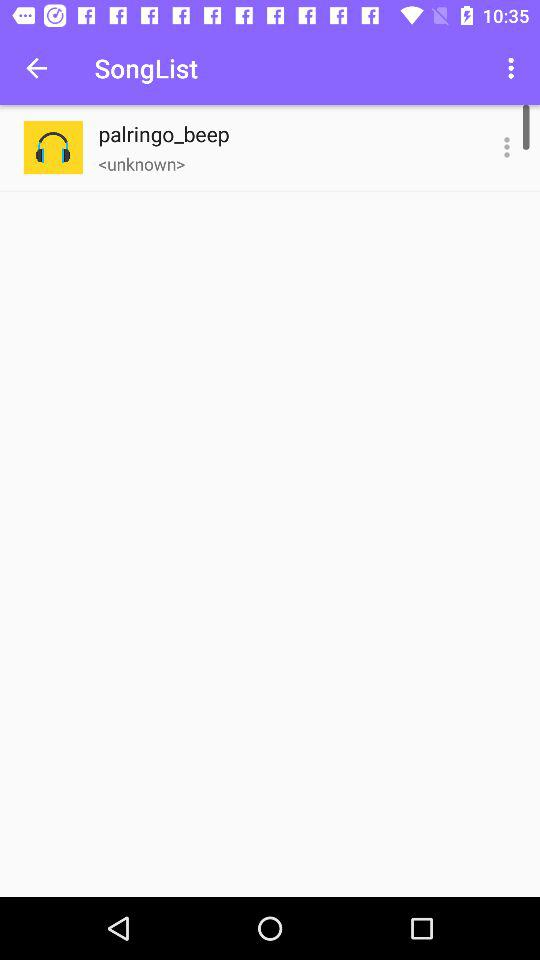What is the title of the song? The title of the song is "palringo_beep". 